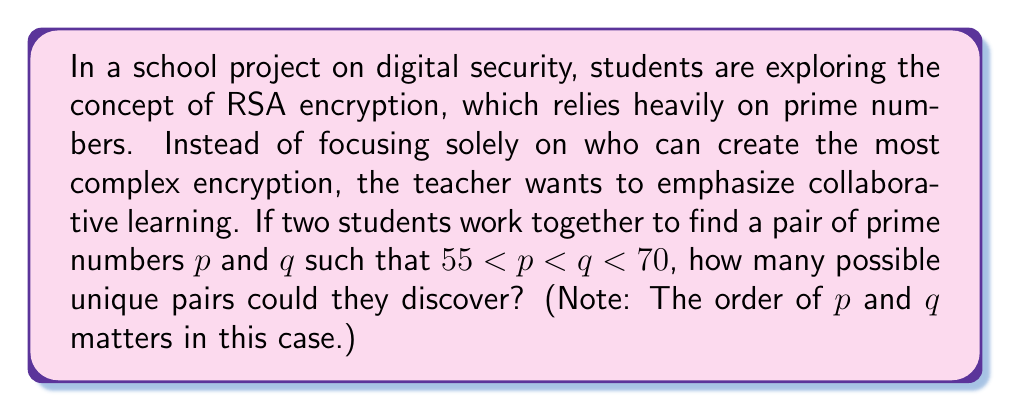Teach me how to tackle this problem. Let's approach this step-by-step:

1) First, we need to identify all the prime numbers between 55 and 70:
   
   The prime numbers in this range are: 59, 61, 67

2) Now, we need to count how many ways we can choose $p$ and $q$ from these primes, where $p < q$:

   Possible pairs:
   (59, 61)
   (59, 67)
   (61, 67)

3) We count the number of pairs:

   There are 3 possible pairs.

This collaborative approach allows students to work together, fostering teamwork and shared learning experiences. It emphasizes the importance of understanding the concept rather than competing to create the most complex encryption. This can help reduce stress and the negative impacts of a winner-takes-all mentality, promoting a healthier learning environment.
Answer: 3 possible pairs 